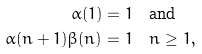<formula> <loc_0><loc_0><loc_500><loc_500>\alpha ( 1 ) & = 1 \quad \text {and} \\ \alpha ( n + 1 ) \beta ( n ) & = 1 \quad n \geq 1 ,</formula> 